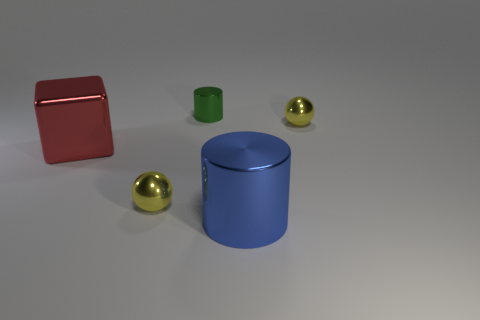Can you describe the colors and shapes of the objects in the image? Certainly! The image displays a variety of shapes and colors. There is a large red block with a reflective surface, a blue cylinder, and two smaller objects: a green cylinder and two golden spheres, all with a smooth finish. Which object stands out the most to you? The large red block stands out due to its vibrant color and significant size compared to the other objects. 